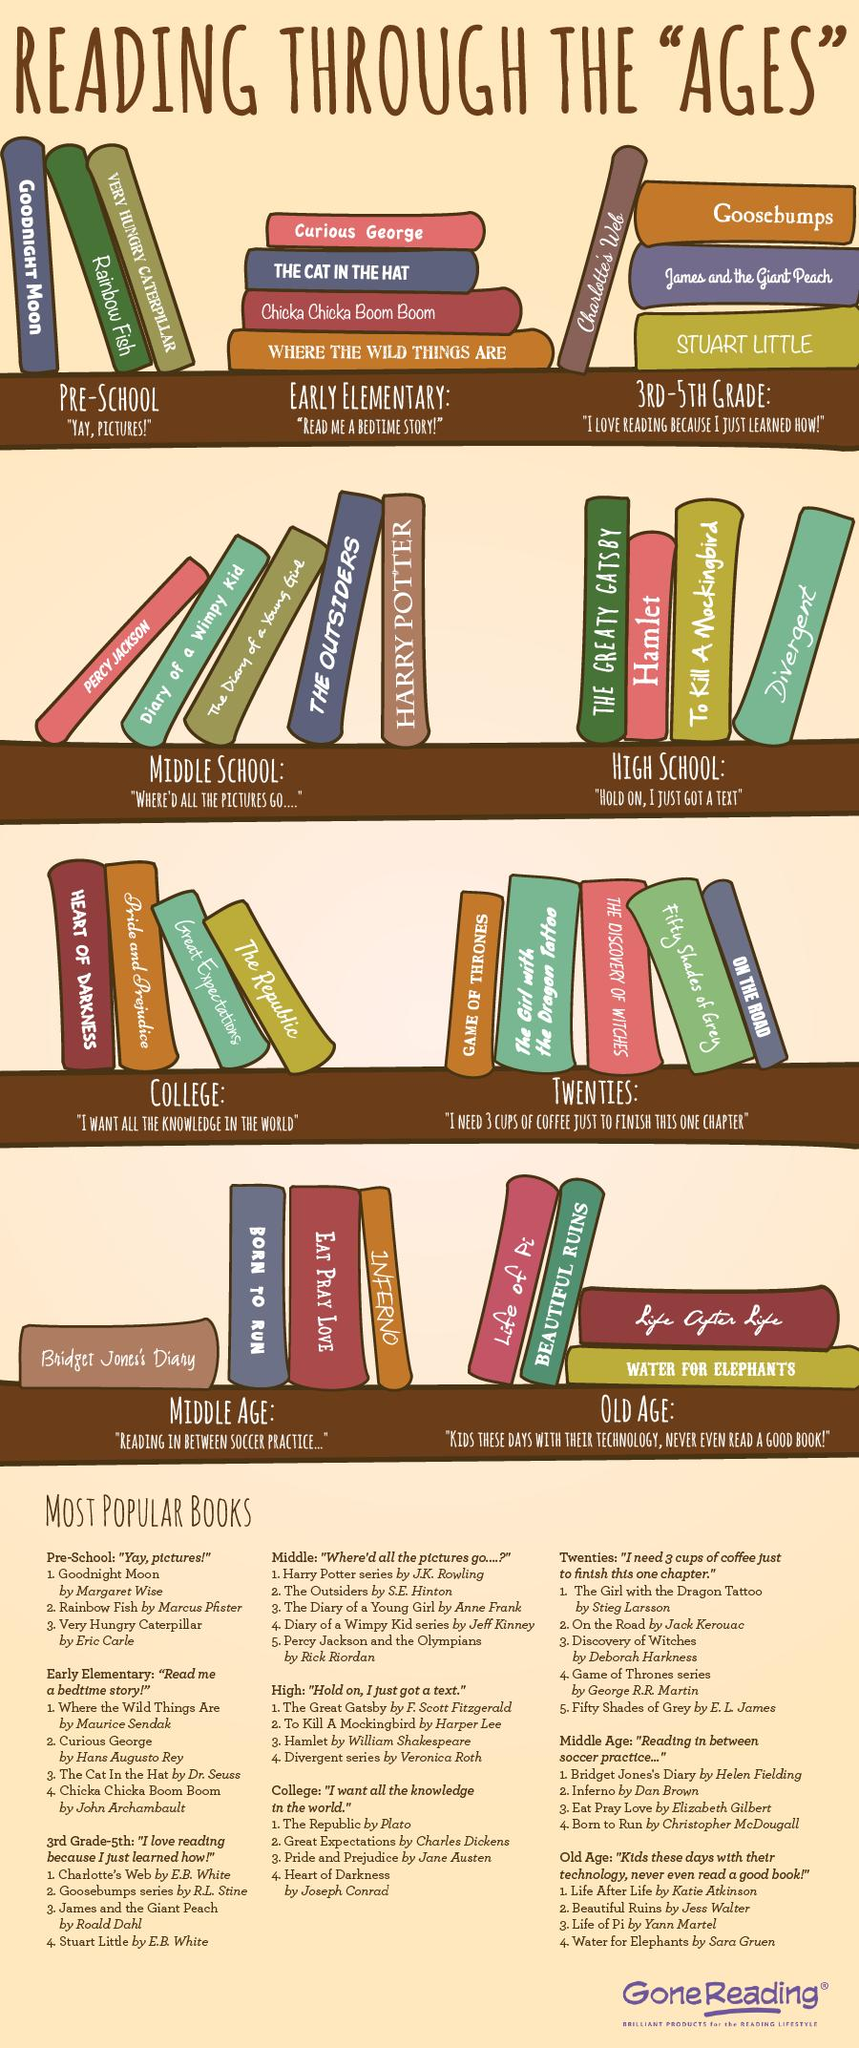Outline some significant characteristics in this image. Hamlet is intended for the high school reading group. Harry Potter is a book that is intended for the middle school age group. Water for Elephants is recommended for the age group of Old Age. Stuart Little is intended for children in the 3rd-5th grade age group. The book "Rainbow Fish" has a color that is either green or white, and the color is green. 